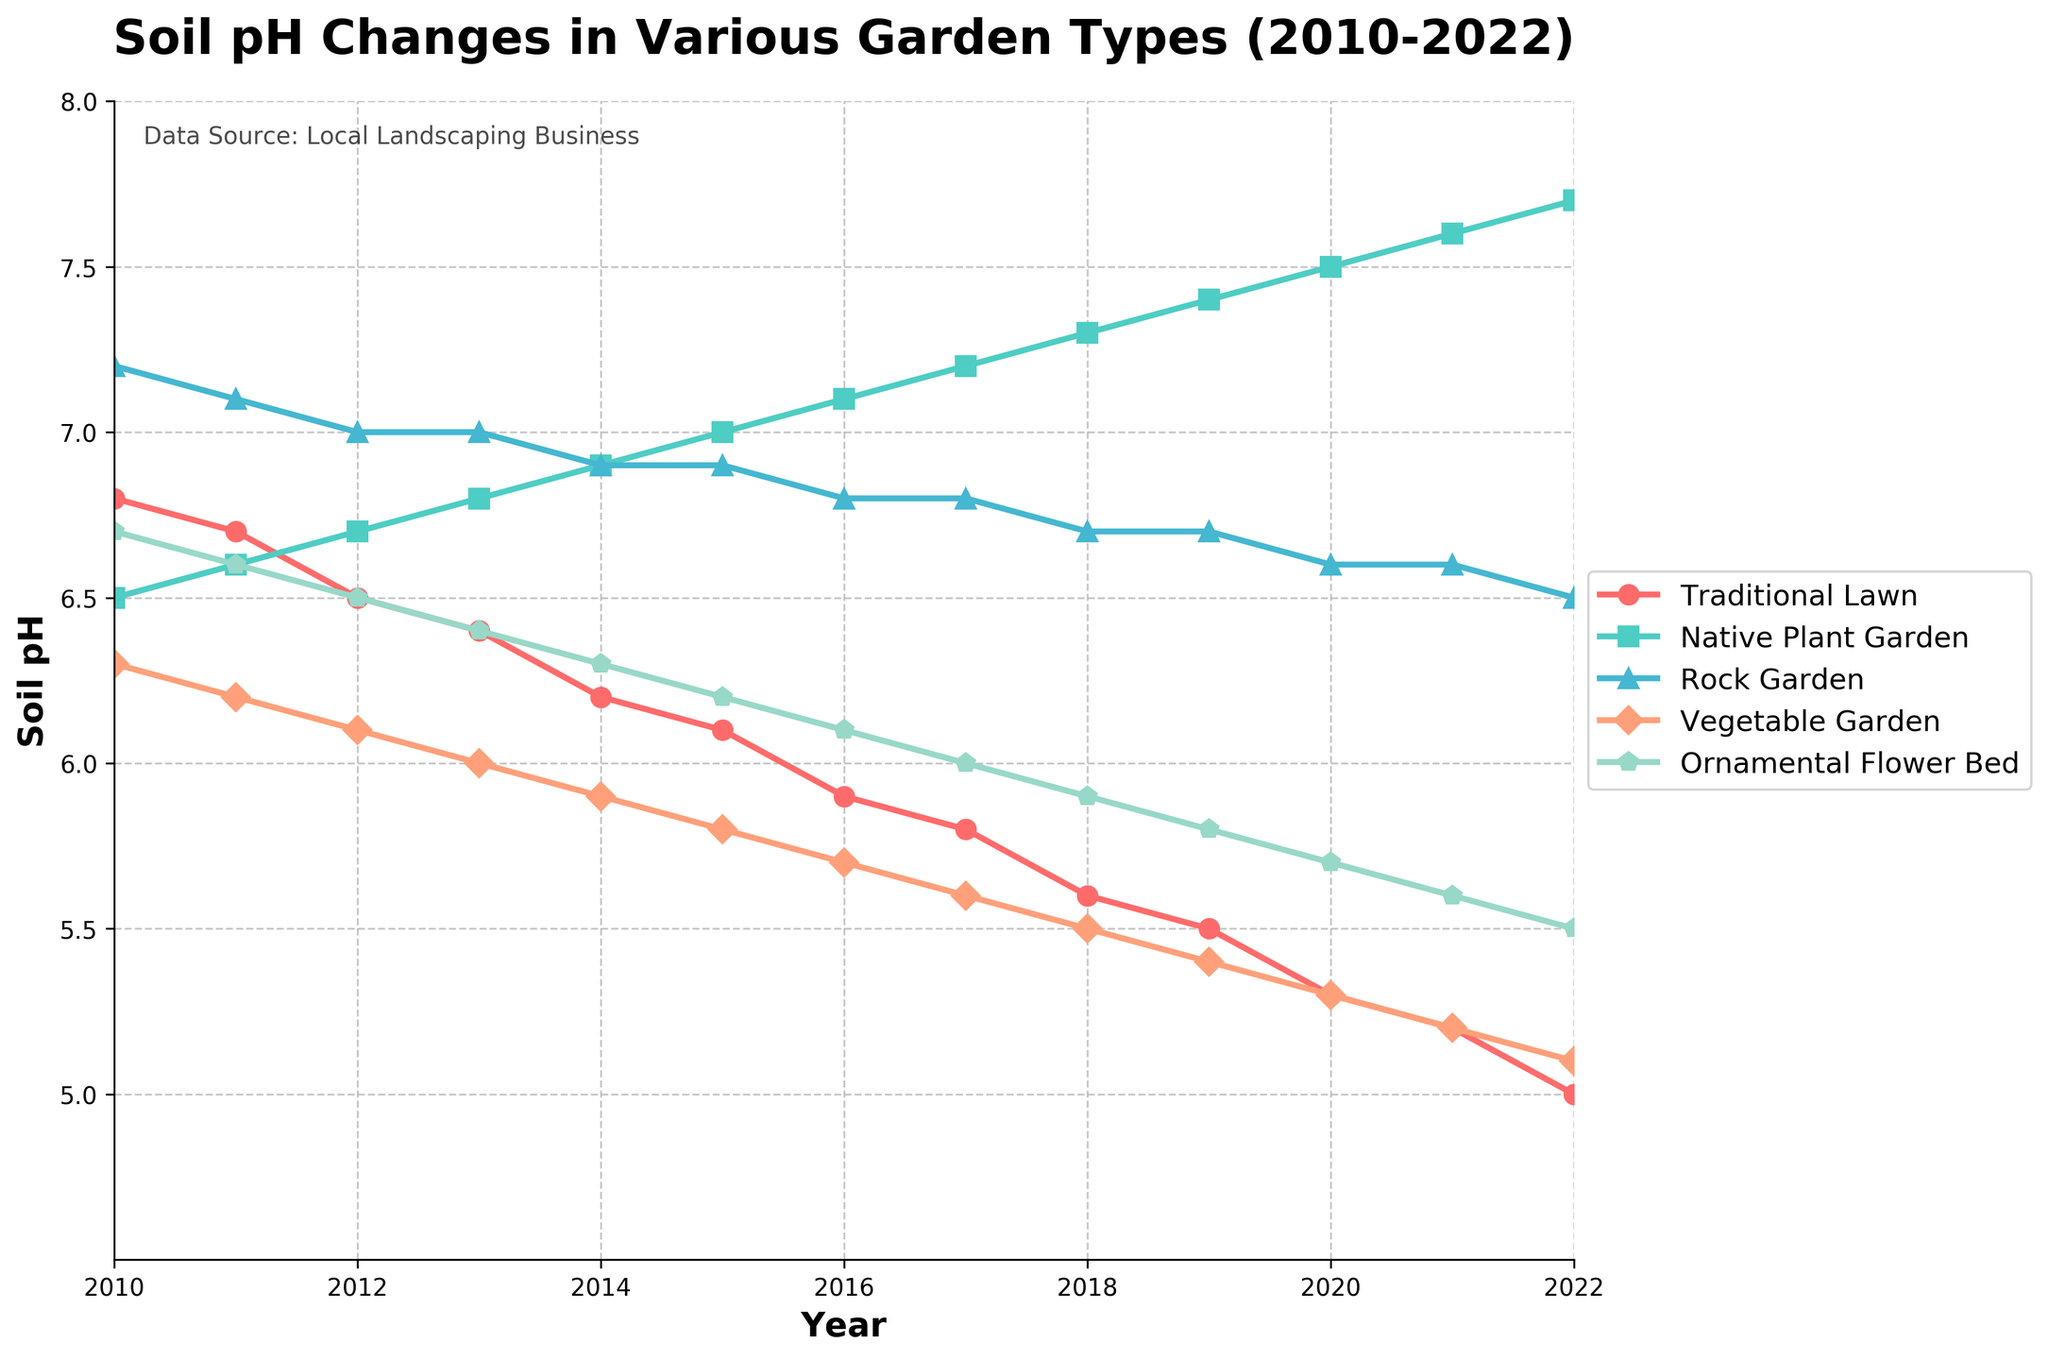What's the difference in soil pH between the Traditional Lawn and the Native Plant Garden in 2022? In 2022, the soil pH for the Traditional Lawn is 5.0 and for the Native Plant Garden is 7.7. The difference is 7.7 - 5.0 = 2.7.
Answer: 2.7 Which garden type had the largest decrease in soil pH from 2010 to 2022? We need to calculate the difference in soil pH for each garden type between 2010 and 2022, then find the largest decrease. Traditional Lawn: 6.8 - 5.0 = 1.8, Native Plant Garden: 7.7 - 6.5 = 1.2, Rock Garden: 7.2 - 6.5 = 0.7, Vegetable Garden: 6.3 - 5.1 = 1.2, Ornamental Flower Bed: 6.7 - 5.5 = 1.2. The largest decrease is in the Traditional Lawn, which is 1.8.
Answer: Traditional Lawn What is the average soil pH of the Rock Garden over the years shown? We need to sum the pH values of the Rock Garden from 2010 to 2022 and divide by the number of years (13). (7.2 + 7.1 + 7.0 + 7.0 + 6.9 + 6.9 + 6.8 + 6.8 + 6.7 + 6.7 + 6.6 + 6.6 + 6.5) / 13 = 89.7 / 13 ≈ 6.9
Answer: 6.9 In which year did the Vegetable Garden have the lowest pH? We look at the soil pH values of the Vegetable Garden for each year and identify the lowest value. The lowest pH for the Vegetable Garden is 5.1 in 2022.
Answer: 2022 Which garden type had a consistently increasing soil pH from 2010 to 2022? We need to check the soil pH trend for each garden type over the years. The Native Plant Garden had a consistently increasing soil pH from 6.5 in 2010 to 7.7 in 2022.
Answer: Native Plant Garden Between 2016 and 2020, by how much did the soil pH of the Ornamental Flower Bed change? We find the soil pH values of the Ornamental Flower Bed in 2016 and 2020 and calculate the difference. In 2016, it was 6.1, and in 2020, it was 5.7. The difference is 6.1 - 5.7 = 0.4.
Answer: 0.4 How does the 2020 soil pH of the Rock Garden compare to the 2015 soil pH of the Traditional Lawn? The soil pH of the Rock Garden in 2020 is 6.6, and the soil pH of the Traditional Lawn in 2015 is 6.1. The Rock Garden's soil pH is higher by 6.6 - 6.1 = 0.5.
Answer: The Rock Garden's soil pH is 0.5 higher 